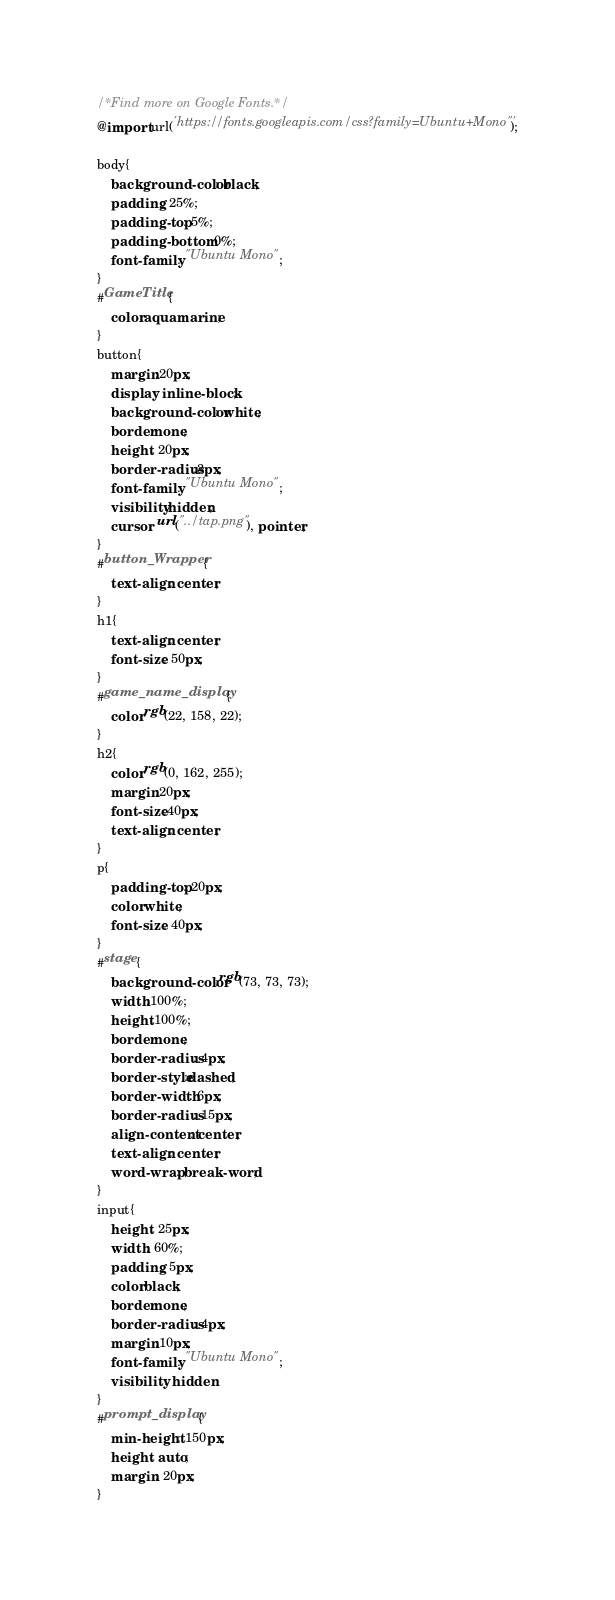<code> <loc_0><loc_0><loc_500><loc_500><_CSS_>/*Find more on Google Fonts.*/
@import url('https://fonts.googleapis.com/css?family=Ubuntu+Mono"');

body{
    background-color: black;
    padding: 25%;
    padding-top: 5%;
    padding-bottom: 0%;
    font-family: "Ubuntu Mono";
}
#GameTitle{
    color:aquamarine;
}
button{
    margin:20px;
    display: inline-block;
    background-color: white;
    border:none;
    height: 20px;
    border-radius:3px;
    font-family: "Ubuntu Mono";
    visibility:hidden;
    cursor: url("../tap.png"), pointer;
}
#button_Wrapper{
    text-align: center;
}
h1{
    text-align: center;
    font-size: 50px;
}
#game_name_display{
    color:rgb(22, 158, 22);
}
h2{
    color:rgb(0, 162, 255);
    margin:20px;
    font-size:40px;
    text-align: center;
}
p{
    padding-top: 20px;
    color:white;
    font-size: 40px;
}
#stage{
    background-color:rgb(73, 73, 73);
    width:100%;
    height:100%;
    border:none;
    border-radius: 4px;
    border-style:dashed;
    border-width: 6px;
    border-radius: 15px;
    align-content: center;
    text-align: center;
    word-wrap: break-word;
}
input{
    height: 25px;
    width: 60%;
    padding: 5px;    
    color:black;
    border:none;
    border-radius: 4px;
    margin:10px;
    font-family: "Ubuntu Mono";
    visibility: hidden
}
#prompt_display{
    min-height: 150px;
    height: auto;
    margin: 20px;
}</code> 